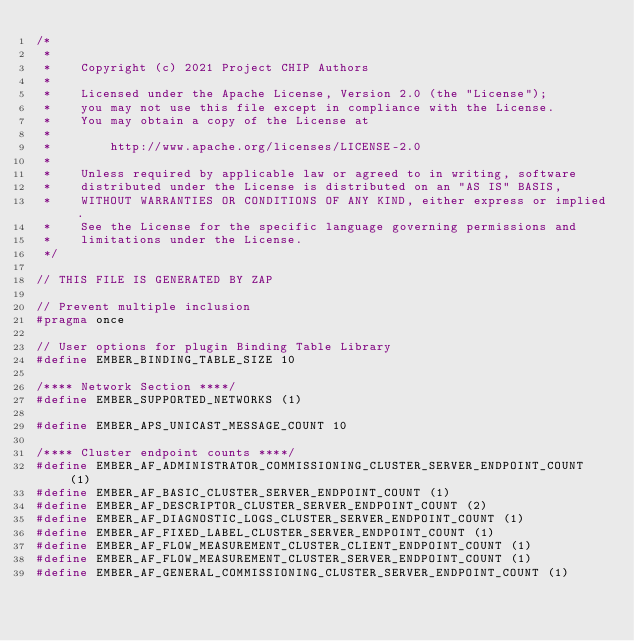Convert code to text. <code><loc_0><loc_0><loc_500><loc_500><_C_>/*
 *
 *    Copyright (c) 2021 Project CHIP Authors
 *
 *    Licensed under the Apache License, Version 2.0 (the "License");
 *    you may not use this file except in compliance with the License.
 *    You may obtain a copy of the License at
 *
 *        http://www.apache.org/licenses/LICENSE-2.0
 *
 *    Unless required by applicable law or agreed to in writing, software
 *    distributed under the License is distributed on an "AS IS" BASIS,
 *    WITHOUT WARRANTIES OR CONDITIONS OF ANY KIND, either express or implied.
 *    See the License for the specific language governing permissions and
 *    limitations under the License.
 */

// THIS FILE IS GENERATED BY ZAP

// Prevent multiple inclusion
#pragma once

// User options for plugin Binding Table Library
#define EMBER_BINDING_TABLE_SIZE 10

/**** Network Section ****/
#define EMBER_SUPPORTED_NETWORKS (1)

#define EMBER_APS_UNICAST_MESSAGE_COUNT 10

/**** Cluster endpoint counts ****/
#define EMBER_AF_ADMINISTRATOR_COMMISSIONING_CLUSTER_SERVER_ENDPOINT_COUNT (1)
#define EMBER_AF_BASIC_CLUSTER_SERVER_ENDPOINT_COUNT (1)
#define EMBER_AF_DESCRIPTOR_CLUSTER_SERVER_ENDPOINT_COUNT (2)
#define EMBER_AF_DIAGNOSTIC_LOGS_CLUSTER_SERVER_ENDPOINT_COUNT (1)
#define EMBER_AF_FIXED_LABEL_CLUSTER_SERVER_ENDPOINT_COUNT (1)
#define EMBER_AF_FLOW_MEASUREMENT_CLUSTER_CLIENT_ENDPOINT_COUNT (1)
#define EMBER_AF_FLOW_MEASUREMENT_CLUSTER_SERVER_ENDPOINT_COUNT (1)
#define EMBER_AF_GENERAL_COMMISSIONING_CLUSTER_SERVER_ENDPOINT_COUNT (1)</code> 